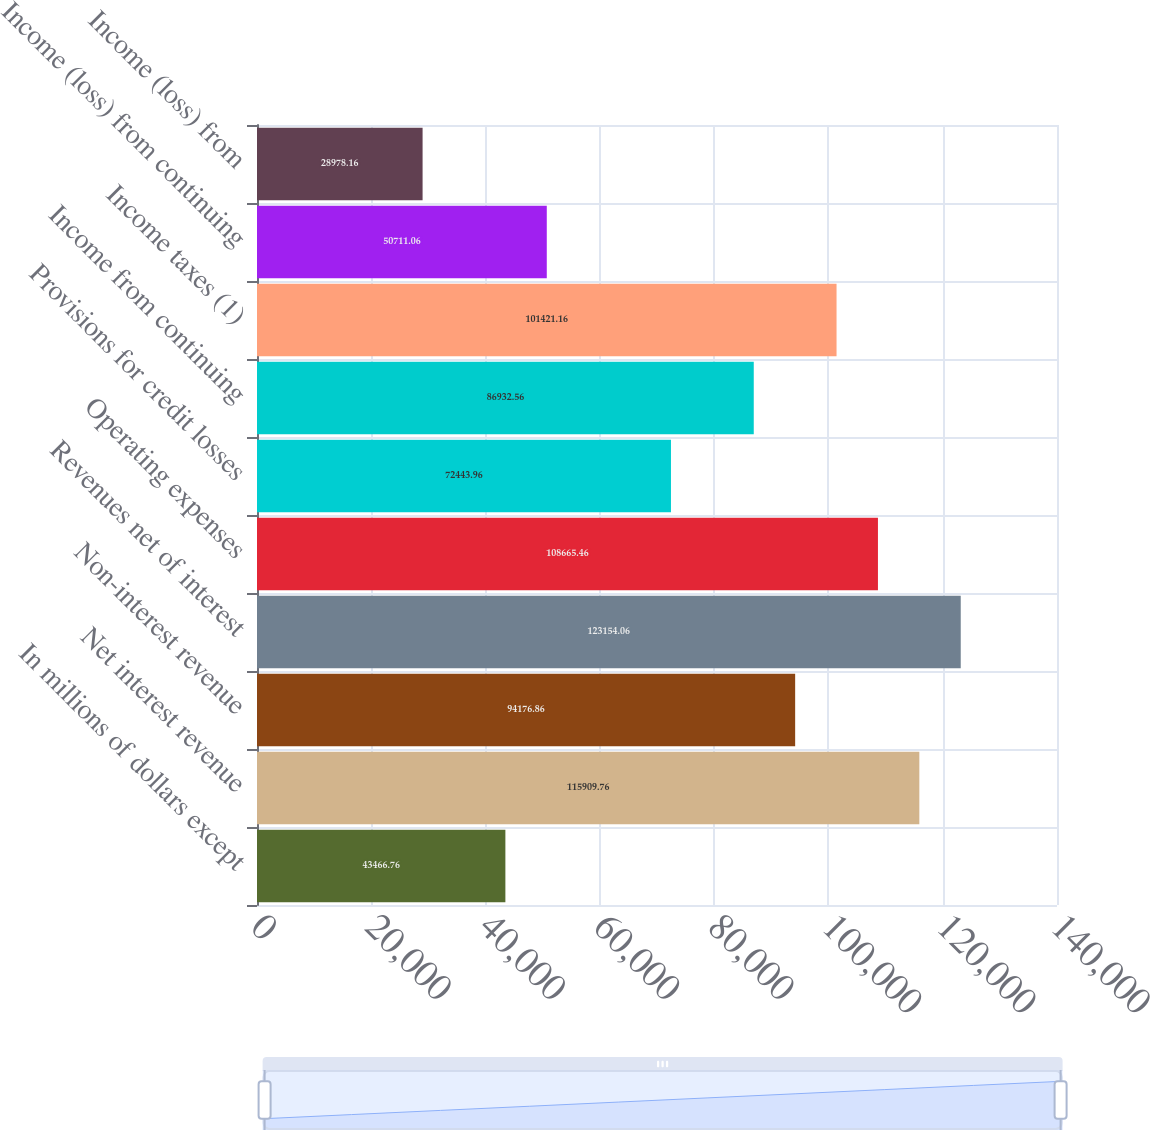<chart> <loc_0><loc_0><loc_500><loc_500><bar_chart><fcel>In millions of dollars except<fcel>Net interest revenue<fcel>Non-interest revenue<fcel>Revenues net of interest<fcel>Operating expenses<fcel>Provisions for credit losses<fcel>Income from continuing<fcel>Income taxes (1)<fcel>Income (loss) from continuing<fcel>Income (loss) from<nl><fcel>43466.8<fcel>115910<fcel>94176.9<fcel>123154<fcel>108665<fcel>72444<fcel>86932.6<fcel>101421<fcel>50711.1<fcel>28978.2<nl></chart> 